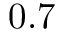Convert formula to latex. <formula><loc_0><loc_0><loc_500><loc_500>0 . 7</formula> 